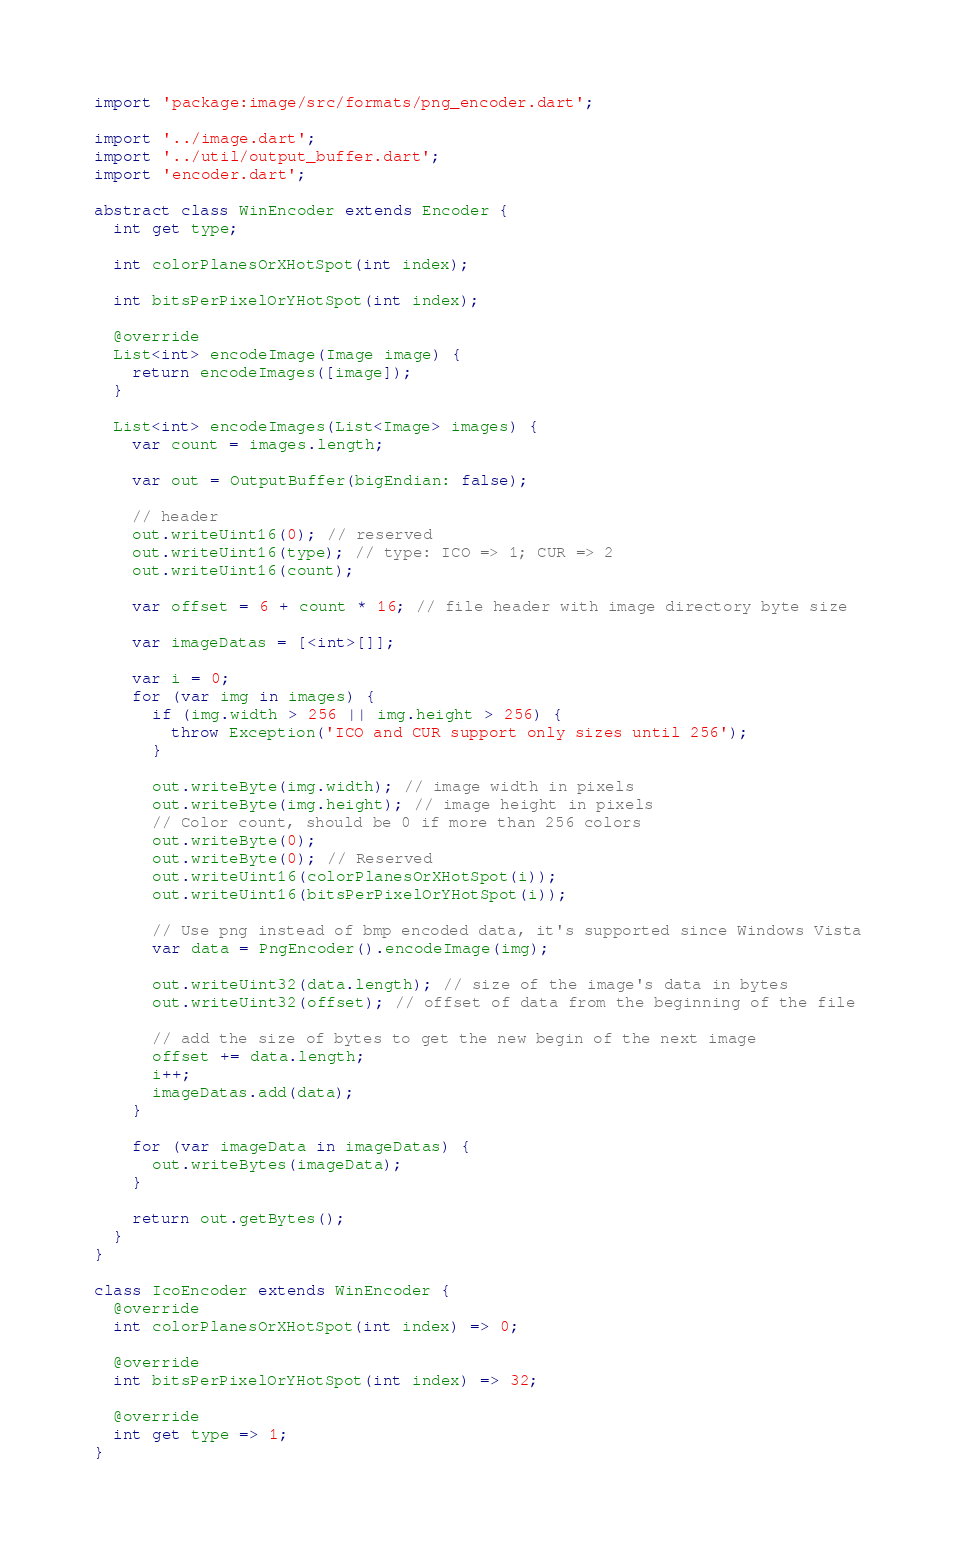<code> <loc_0><loc_0><loc_500><loc_500><_Dart_>
import 'package:image/src/formats/png_encoder.dart';

import '../image.dart';
import '../util/output_buffer.dart';
import 'encoder.dart';

abstract class WinEncoder extends Encoder {
  int get type;

  int colorPlanesOrXHotSpot(int index);

  int bitsPerPixelOrYHotSpot(int index);

  @override
  List<int> encodeImage(Image image) {
    return encodeImages([image]);
  }

  List<int> encodeImages(List<Image> images) {
    var count = images.length;

    var out = OutputBuffer(bigEndian: false);

    // header
    out.writeUint16(0); // reserved
    out.writeUint16(type); // type: ICO => 1; CUR => 2
    out.writeUint16(count);

    var offset = 6 + count * 16; // file header with image directory byte size

    var imageDatas = [<int>[]];

    var i = 0;
    for (var img in images) {
      if (img.width > 256 || img.height > 256) {
        throw Exception('ICO and CUR support only sizes until 256');
      }

      out.writeByte(img.width); // image width in pixels
      out.writeByte(img.height); // image height in pixels
      // Color count, should be 0 if more than 256 colors
      out.writeByte(0);
      out.writeByte(0); // Reserved
      out.writeUint16(colorPlanesOrXHotSpot(i));
      out.writeUint16(bitsPerPixelOrYHotSpot(i));

      // Use png instead of bmp encoded data, it's supported since Windows Vista
      var data = PngEncoder().encodeImage(img);

      out.writeUint32(data.length); // size of the image's data in bytes
      out.writeUint32(offset); // offset of data from the beginning of the file

      // add the size of bytes to get the new begin of the next image
      offset += data.length;
      i++;
      imageDatas.add(data);
    }

    for (var imageData in imageDatas) {
      out.writeBytes(imageData);
    }

    return out.getBytes();
  }
}

class IcoEncoder extends WinEncoder {
  @override
  int colorPlanesOrXHotSpot(int index) => 0;

  @override
  int bitsPerPixelOrYHotSpot(int index) => 32;

  @override
  int get type => 1;
}
</code> 